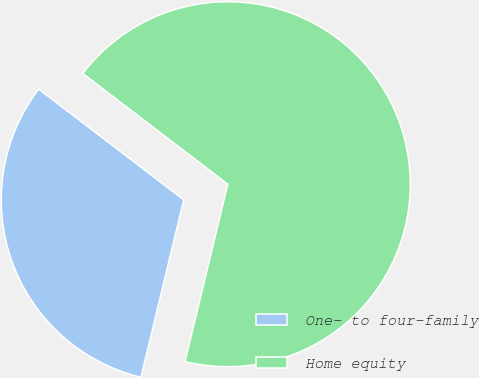Convert chart. <chart><loc_0><loc_0><loc_500><loc_500><pie_chart><fcel>One- to four-family<fcel>Home equity<nl><fcel>31.61%<fcel>68.39%<nl></chart> 